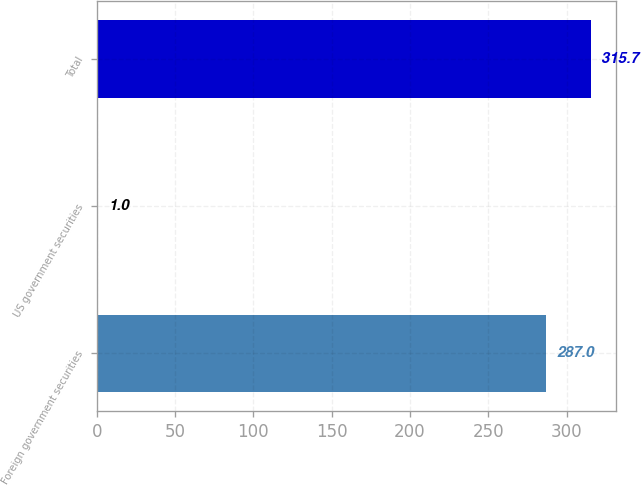<chart> <loc_0><loc_0><loc_500><loc_500><bar_chart><fcel>Foreign government securities<fcel>US government securities<fcel>Total<nl><fcel>287<fcel>1<fcel>315.7<nl></chart> 